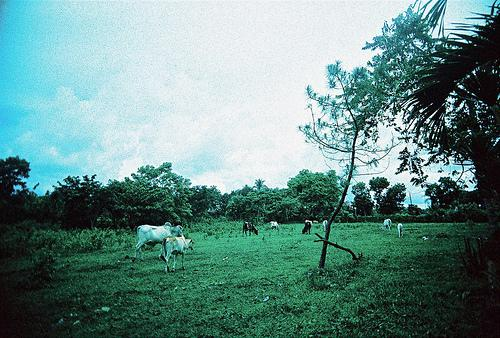Question: where are these animals?
Choices:
A. In a  spaceship.
B. In a field.
C. In a zoo.
D. On a train.
Answer with the letter. Answer: B Question: how does the sky appear?
Choices:
A. Sunny.
B. Cloudy.
C. Filled with fireworks.
D. Filled with birds.
Answer with the letter. Answer: B Question: how does the grass appear?
Choices:
A. Green.
B. Blue.
C. Yellow.
D. Orange.
Answer with the letter. Answer: A Question: what color are these animals?
Choices:
A. Blue and orange.
B. White and black.
C. Yellow and Green.
D. Red and purple.
Answer with the letter. Answer: B Question: what are these animals doing?
Choices:
A. Eating.
B. Laughing.
C. Sneezing.
D. Talking.
Answer with the letter. Answer: A Question: what is in the background?
Choices:
A. Flowers.
B. Buildings.
C. Trees.
D. Animals.
Answer with the letter. Answer: C Question: when was this picture taken?
Choices:
A. Nighttime.
B. In the future.
C. Day time.
D. Afternoon.
Answer with the letter. Answer: C 